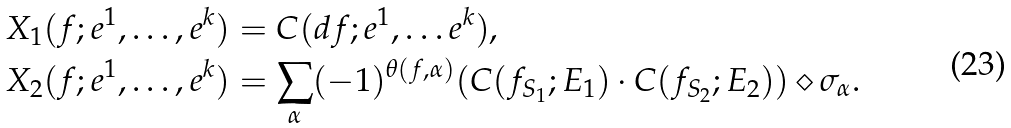Convert formula to latex. <formula><loc_0><loc_0><loc_500><loc_500>X _ { 1 } ( f ; e ^ { 1 } , \dots , e ^ { k } ) & = C ( d f ; e ^ { 1 } , \dots e ^ { k } ) , \\ X _ { 2 } ( f ; e ^ { 1 } , \dots , e ^ { k } ) & = \sum _ { \alpha } ( - 1 ) ^ { \theta ( f , \alpha ) } ( C ( f _ { S _ { 1 } } ; E _ { 1 } ) \cdot C ( f _ { S _ { 2 } } ; E _ { 2 } ) ) \diamond \sigma _ { \alpha } .</formula> 